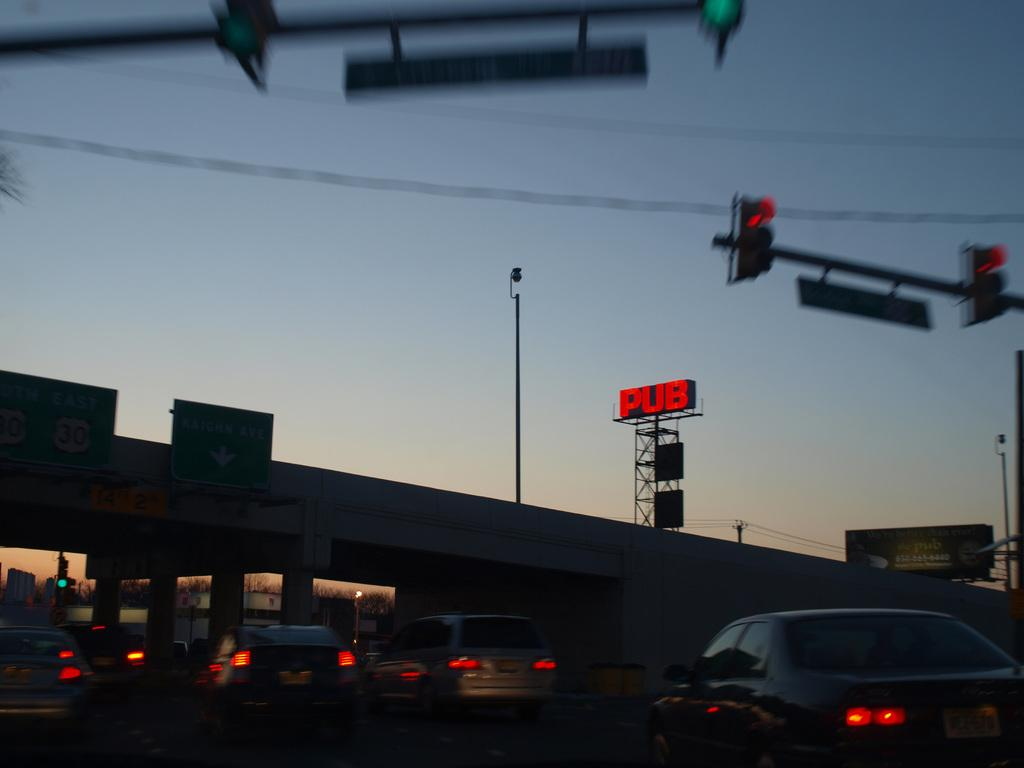<image>
Relay a brief, clear account of the picture shown. A busy street at dusk and a sign on a tall tower says PUB in red letters. 